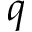<formula> <loc_0><loc_0><loc_500><loc_500>q</formula> 